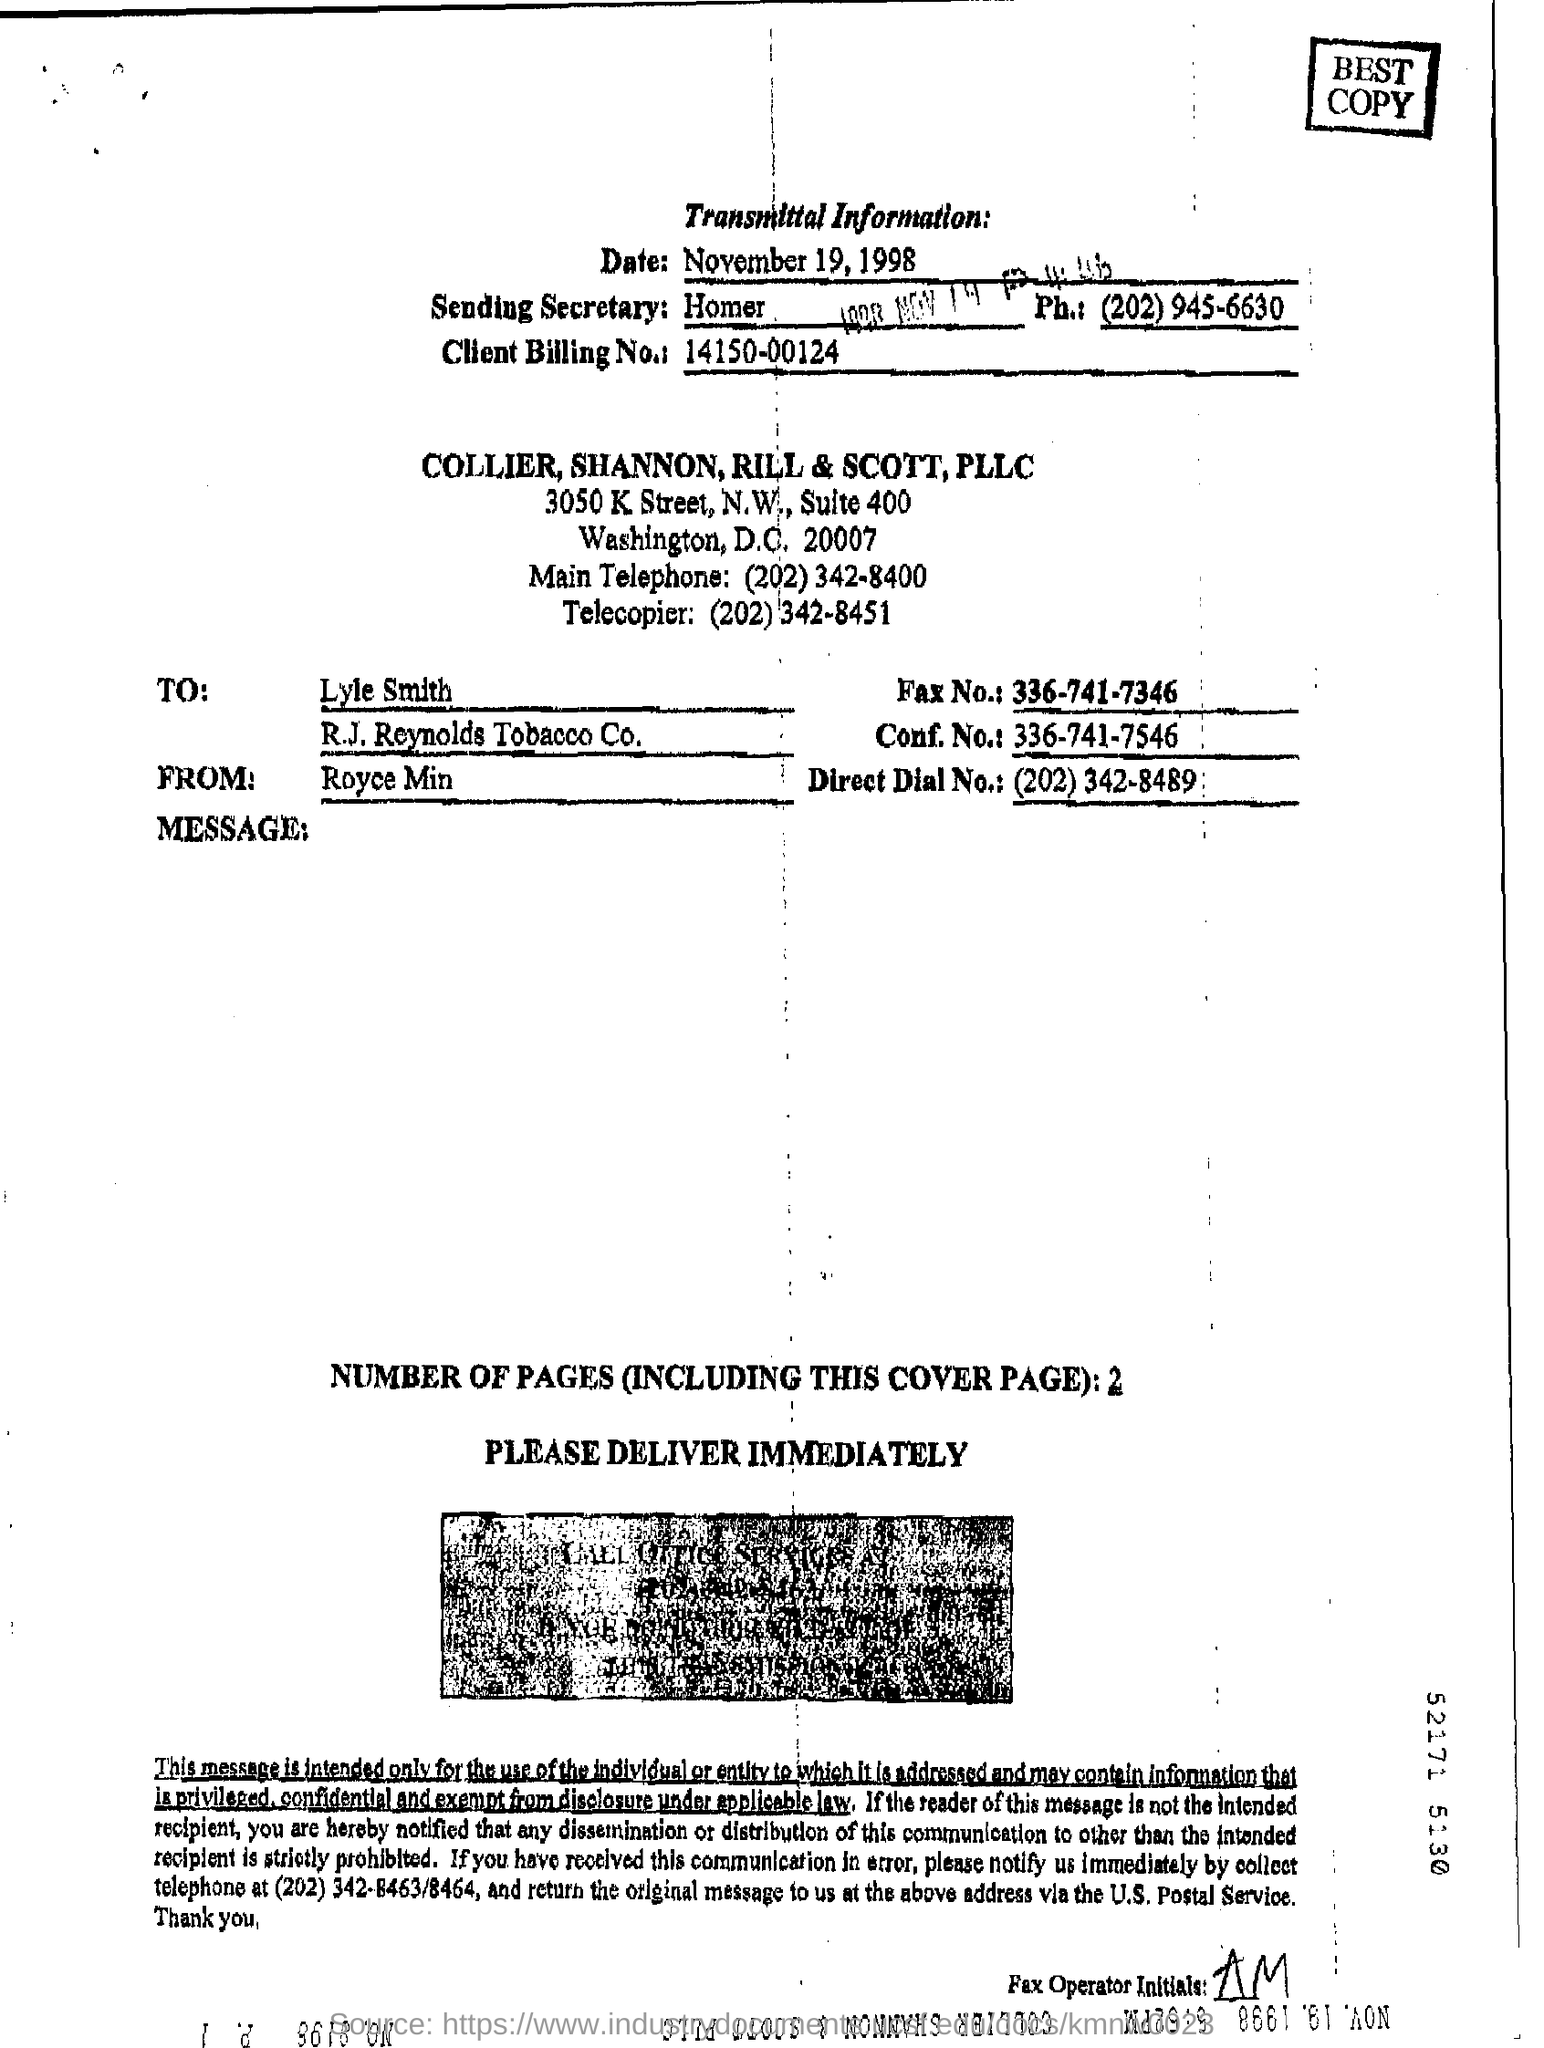What is client billing no:
Offer a terse response. 14150-00124. Who is at the receiver's end?
Provide a succinct answer. Lyle Smith. 